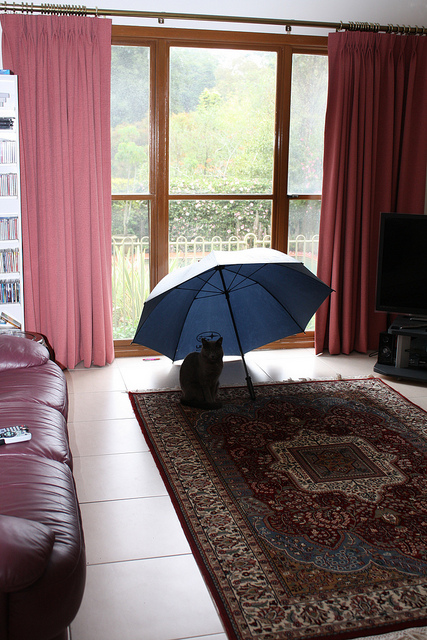What is unusual about what the cat is doing? Cats generally don't use umbrellas, so seeing this cat sitting calmly under a blue umbrella indoors is quite an amusing and adorable oddity! 